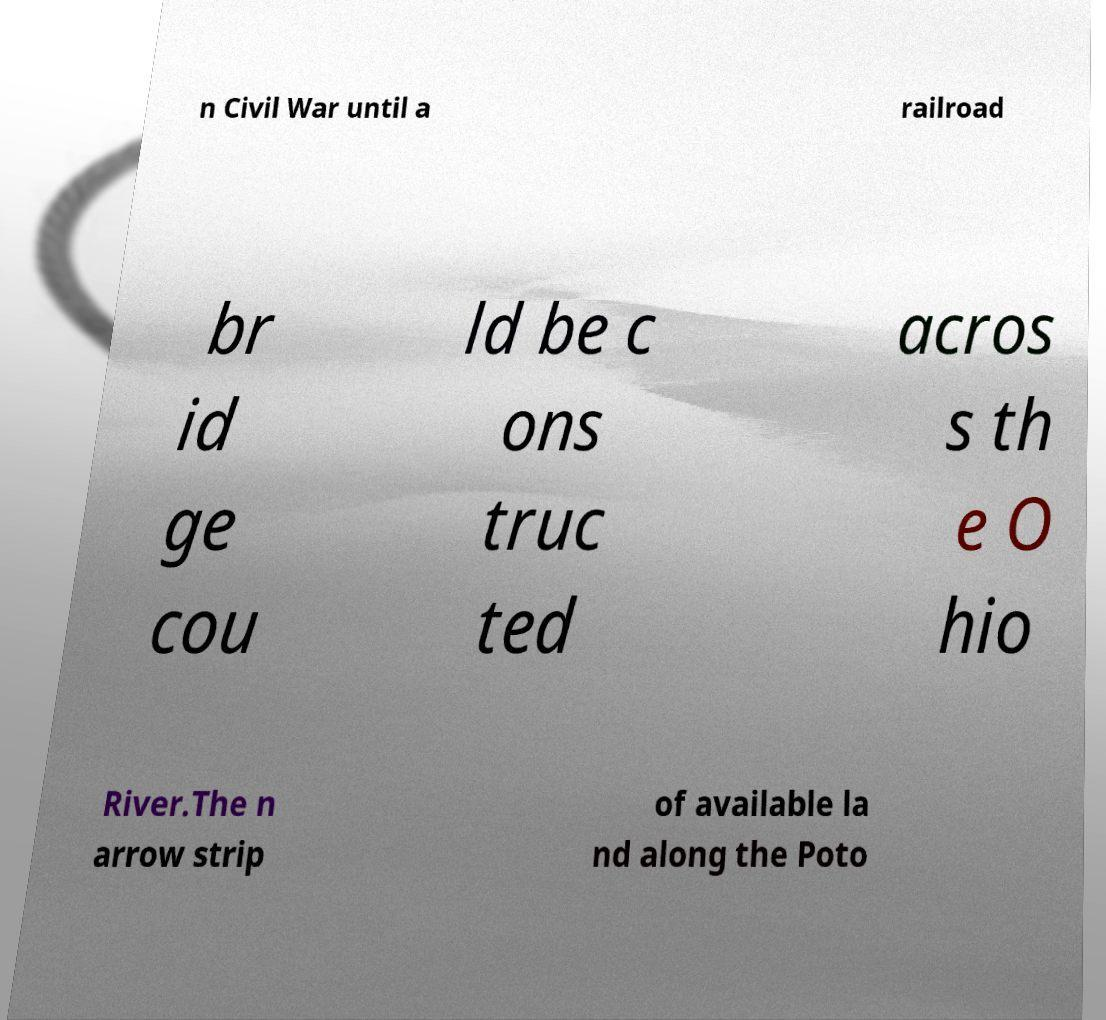For documentation purposes, I need the text within this image transcribed. Could you provide that? n Civil War until a railroad br id ge cou ld be c ons truc ted acros s th e O hio River.The n arrow strip of available la nd along the Poto 